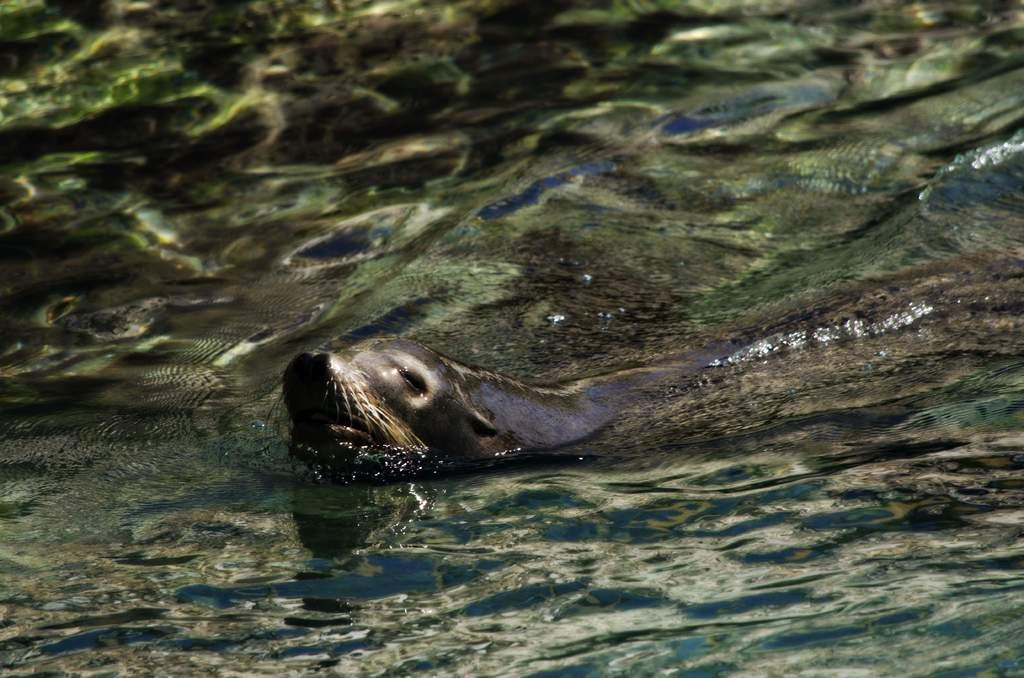What type of animal is in the center of the image? There is a water animal in the center of the image. What is the primary element surrounding the animal? There is water visible at the bottom of the image. What type of jewel is being used as a calendar in the image? There is no jewel or calendar present in the image; it features a water animal in water. 